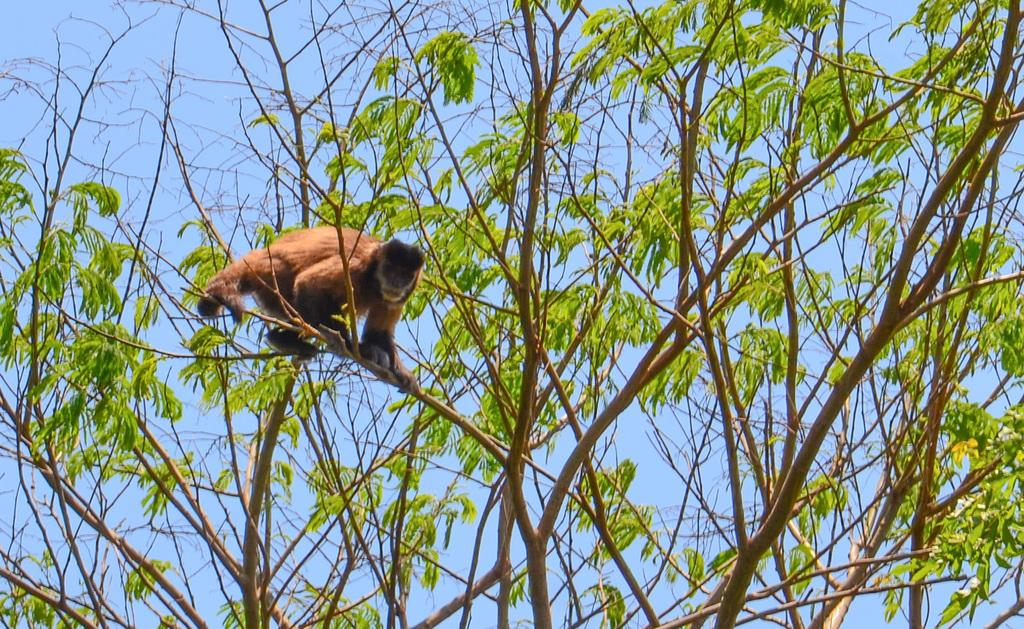What animal is present in the image? There is a monkey in the image. Where is the monkey located? The monkey is on a branch of a tree. What can be seen in the background of the image? There is sky visible in the background of the image. How many horses are visible in the image, and where are they located in the image? There are no horses present in the image. What type of stone is the monkey sitting on in the image? The monkey is not sitting on a stone; it is on a branch of a tree. 